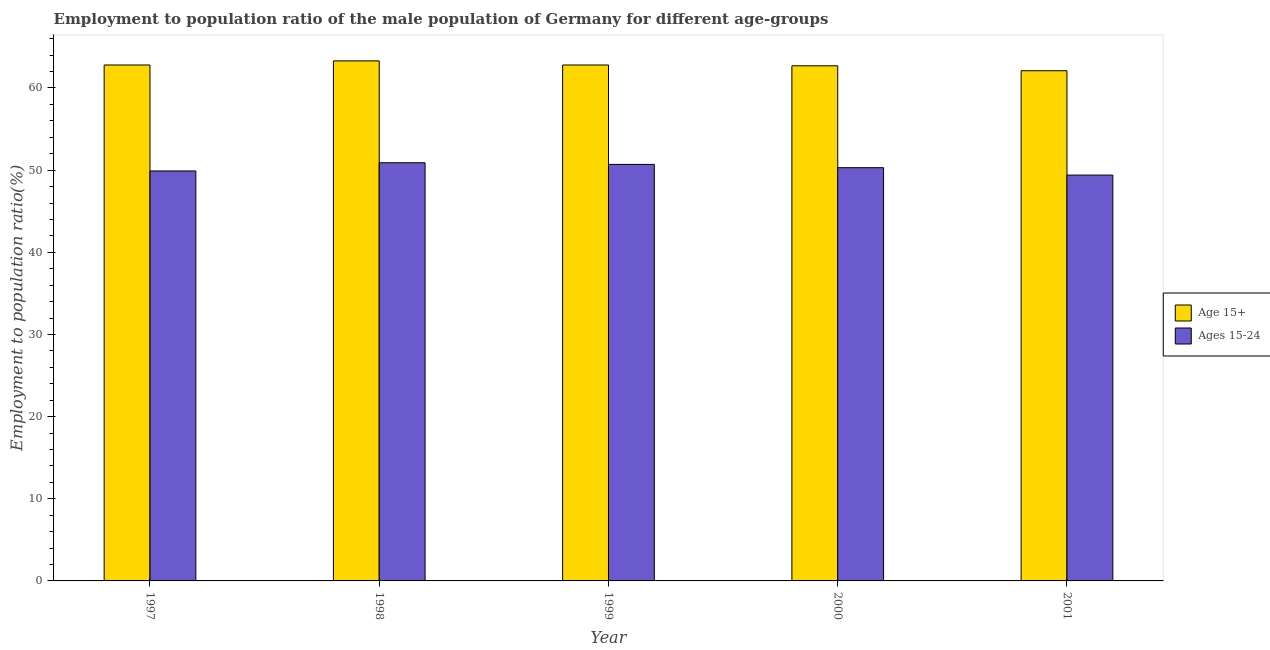How many bars are there on the 3rd tick from the right?
Offer a terse response. 2. What is the employment to population ratio(age 15+) in 1999?
Make the answer very short. 62.8. Across all years, what is the maximum employment to population ratio(age 15-24)?
Your answer should be very brief. 50.9. Across all years, what is the minimum employment to population ratio(age 15-24)?
Keep it short and to the point. 49.4. In which year was the employment to population ratio(age 15-24) minimum?
Ensure brevity in your answer.  2001. What is the total employment to population ratio(age 15+) in the graph?
Your answer should be compact. 313.7. What is the difference between the employment to population ratio(age 15+) in 1998 and that in 1999?
Keep it short and to the point. 0.5. What is the difference between the employment to population ratio(age 15-24) in 2001 and the employment to population ratio(age 15+) in 2000?
Provide a short and direct response. -0.9. What is the average employment to population ratio(age 15-24) per year?
Offer a very short reply. 50.24. In the year 1999, what is the difference between the employment to population ratio(age 15-24) and employment to population ratio(age 15+)?
Give a very brief answer. 0. What is the ratio of the employment to population ratio(age 15+) in 1997 to that in 1998?
Your answer should be compact. 0.99. Is the employment to population ratio(age 15+) in 2000 less than that in 2001?
Make the answer very short. No. Is the difference between the employment to population ratio(age 15+) in 1998 and 1999 greater than the difference between the employment to population ratio(age 15-24) in 1998 and 1999?
Make the answer very short. No. What is the difference between the highest and the second highest employment to population ratio(age 15-24)?
Make the answer very short. 0.2. What does the 2nd bar from the left in 1998 represents?
Provide a short and direct response. Ages 15-24. What does the 1st bar from the right in 1999 represents?
Offer a terse response. Ages 15-24. How many bars are there?
Your answer should be very brief. 10. What is the difference between two consecutive major ticks on the Y-axis?
Your answer should be compact. 10. Are the values on the major ticks of Y-axis written in scientific E-notation?
Give a very brief answer. No. How many legend labels are there?
Ensure brevity in your answer.  2. What is the title of the graph?
Your response must be concise. Employment to population ratio of the male population of Germany for different age-groups. Does "RDB concessional" appear as one of the legend labels in the graph?
Your answer should be compact. No. What is the Employment to population ratio(%) in Age 15+ in 1997?
Offer a very short reply. 62.8. What is the Employment to population ratio(%) in Ages 15-24 in 1997?
Offer a very short reply. 49.9. What is the Employment to population ratio(%) in Age 15+ in 1998?
Your answer should be compact. 63.3. What is the Employment to population ratio(%) in Ages 15-24 in 1998?
Offer a terse response. 50.9. What is the Employment to population ratio(%) of Age 15+ in 1999?
Provide a succinct answer. 62.8. What is the Employment to population ratio(%) of Ages 15-24 in 1999?
Keep it short and to the point. 50.7. What is the Employment to population ratio(%) in Age 15+ in 2000?
Give a very brief answer. 62.7. What is the Employment to population ratio(%) of Ages 15-24 in 2000?
Provide a succinct answer. 50.3. What is the Employment to population ratio(%) in Age 15+ in 2001?
Your answer should be very brief. 62.1. What is the Employment to population ratio(%) in Ages 15-24 in 2001?
Offer a very short reply. 49.4. Across all years, what is the maximum Employment to population ratio(%) of Age 15+?
Make the answer very short. 63.3. Across all years, what is the maximum Employment to population ratio(%) in Ages 15-24?
Provide a succinct answer. 50.9. Across all years, what is the minimum Employment to population ratio(%) of Age 15+?
Your answer should be very brief. 62.1. Across all years, what is the minimum Employment to population ratio(%) of Ages 15-24?
Offer a very short reply. 49.4. What is the total Employment to population ratio(%) of Age 15+ in the graph?
Your answer should be very brief. 313.7. What is the total Employment to population ratio(%) of Ages 15-24 in the graph?
Provide a succinct answer. 251.2. What is the difference between the Employment to population ratio(%) in Age 15+ in 1997 and that in 1999?
Make the answer very short. 0. What is the difference between the Employment to population ratio(%) in Age 15+ in 1997 and that in 2000?
Provide a short and direct response. 0.1. What is the difference between the Employment to population ratio(%) in Ages 15-24 in 1997 and that in 2000?
Your response must be concise. -0.4. What is the difference between the Employment to population ratio(%) of Ages 15-24 in 1997 and that in 2001?
Offer a very short reply. 0.5. What is the difference between the Employment to population ratio(%) of Age 15+ in 1998 and that in 1999?
Make the answer very short. 0.5. What is the difference between the Employment to population ratio(%) in Ages 15-24 in 1998 and that in 1999?
Provide a succinct answer. 0.2. What is the difference between the Employment to population ratio(%) of Ages 15-24 in 1998 and that in 2000?
Provide a short and direct response. 0.6. What is the difference between the Employment to population ratio(%) of Age 15+ in 1998 and that in 2001?
Offer a very short reply. 1.2. What is the difference between the Employment to population ratio(%) in Ages 15-24 in 1998 and that in 2001?
Your response must be concise. 1.5. What is the difference between the Employment to population ratio(%) in Ages 15-24 in 1999 and that in 2001?
Offer a terse response. 1.3. What is the difference between the Employment to population ratio(%) in Age 15+ in 2000 and that in 2001?
Provide a succinct answer. 0.6. What is the difference between the Employment to population ratio(%) of Age 15+ in 1997 and the Employment to population ratio(%) of Ages 15-24 in 1999?
Your response must be concise. 12.1. What is the difference between the Employment to population ratio(%) of Age 15+ in 1997 and the Employment to population ratio(%) of Ages 15-24 in 2000?
Give a very brief answer. 12.5. What is the difference between the Employment to population ratio(%) of Age 15+ in 1997 and the Employment to population ratio(%) of Ages 15-24 in 2001?
Provide a short and direct response. 13.4. What is the difference between the Employment to population ratio(%) in Age 15+ in 1998 and the Employment to population ratio(%) in Ages 15-24 in 2000?
Your response must be concise. 13. What is the difference between the Employment to population ratio(%) in Age 15+ in 1999 and the Employment to population ratio(%) in Ages 15-24 in 2000?
Your response must be concise. 12.5. What is the difference between the Employment to population ratio(%) in Age 15+ in 1999 and the Employment to population ratio(%) in Ages 15-24 in 2001?
Ensure brevity in your answer.  13.4. What is the average Employment to population ratio(%) of Age 15+ per year?
Provide a short and direct response. 62.74. What is the average Employment to population ratio(%) in Ages 15-24 per year?
Give a very brief answer. 50.24. In the year 1998, what is the difference between the Employment to population ratio(%) of Age 15+ and Employment to population ratio(%) of Ages 15-24?
Give a very brief answer. 12.4. In the year 1999, what is the difference between the Employment to population ratio(%) in Age 15+ and Employment to population ratio(%) in Ages 15-24?
Your answer should be very brief. 12.1. In the year 2000, what is the difference between the Employment to population ratio(%) of Age 15+ and Employment to population ratio(%) of Ages 15-24?
Offer a very short reply. 12.4. What is the ratio of the Employment to population ratio(%) of Ages 15-24 in 1997 to that in 1998?
Your answer should be very brief. 0.98. What is the ratio of the Employment to population ratio(%) in Ages 15-24 in 1997 to that in 1999?
Make the answer very short. 0.98. What is the ratio of the Employment to population ratio(%) of Age 15+ in 1997 to that in 2000?
Provide a succinct answer. 1. What is the ratio of the Employment to population ratio(%) in Ages 15-24 in 1997 to that in 2000?
Provide a short and direct response. 0.99. What is the ratio of the Employment to population ratio(%) of Age 15+ in 1997 to that in 2001?
Give a very brief answer. 1.01. What is the ratio of the Employment to population ratio(%) in Ages 15-24 in 1997 to that in 2001?
Provide a succinct answer. 1.01. What is the ratio of the Employment to population ratio(%) in Ages 15-24 in 1998 to that in 1999?
Ensure brevity in your answer.  1. What is the ratio of the Employment to population ratio(%) in Age 15+ in 1998 to that in 2000?
Provide a short and direct response. 1.01. What is the ratio of the Employment to population ratio(%) of Ages 15-24 in 1998 to that in 2000?
Your answer should be very brief. 1.01. What is the ratio of the Employment to population ratio(%) in Age 15+ in 1998 to that in 2001?
Your answer should be very brief. 1.02. What is the ratio of the Employment to population ratio(%) of Ages 15-24 in 1998 to that in 2001?
Your response must be concise. 1.03. What is the ratio of the Employment to population ratio(%) of Age 15+ in 1999 to that in 2001?
Your answer should be very brief. 1.01. What is the ratio of the Employment to population ratio(%) of Ages 15-24 in 1999 to that in 2001?
Offer a very short reply. 1.03. What is the ratio of the Employment to population ratio(%) of Age 15+ in 2000 to that in 2001?
Provide a succinct answer. 1.01. What is the ratio of the Employment to population ratio(%) in Ages 15-24 in 2000 to that in 2001?
Make the answer very short. 1.02. What is the difference between the highest and the lowest Employment to population ratio(%) in Ages 15-24?
Offer a very short reply. 1.5. 